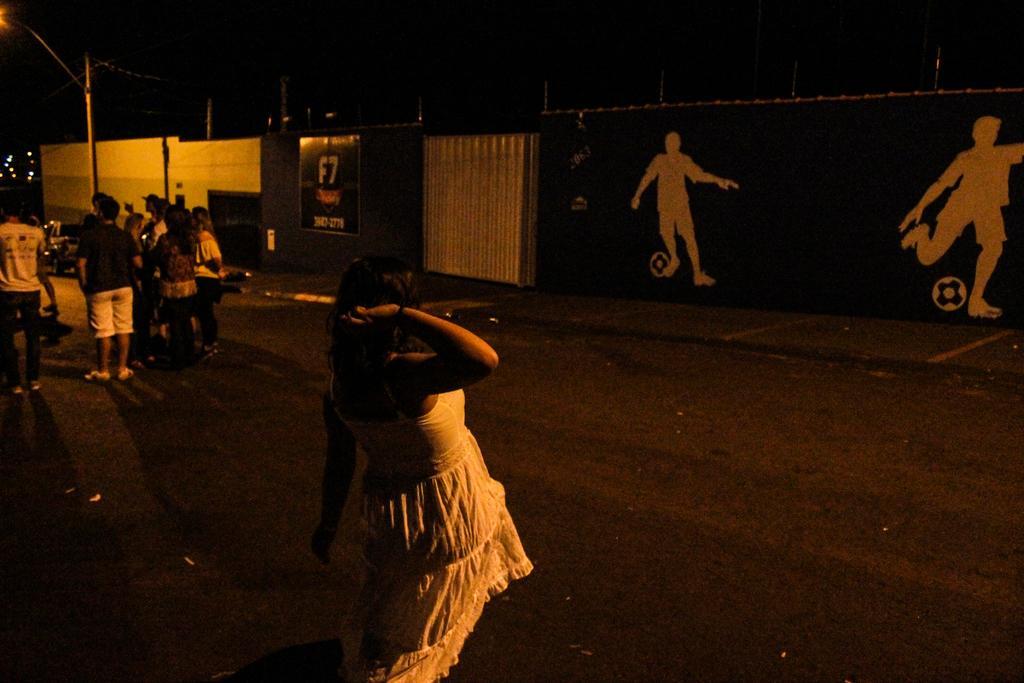Could you give a brief overview of what you see in this image? In this picture I can see the road on which there are number of people who are standing and in the background I can see the wall on which I can see something is written and I can see an art. On the left side of this picture I can see a pole and I see that this picture is in dark. 